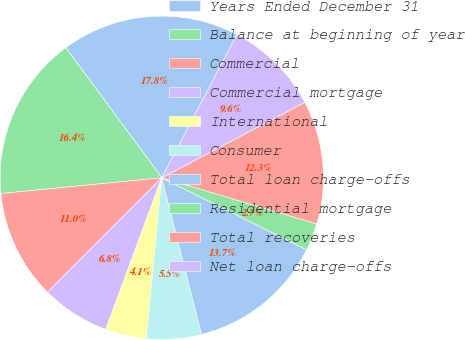Convert chart. <chart><loc_0><loc_0><loc_500><loc_500><pie_chart><fcel>Years Ended December 31<fcel>Balance at beginning of year<fcel>Commercial<fcel>Commercial mortgage<fcel>International<fcel>Consumer<fcel>Total loan charge-offs<fcel>Residential mortgage<fcel>Total recoveries<fcel>Net loan charge-offs<nl><fcel>17.81%<fcel>16.44%<fcel>10.96%<fcel>6.85%<fcel>4.11%<fcel>5.48%<fcel>13.7%<fcel>2.74%<fcel>12.33%<fcel>9.59%<nl></chart> 